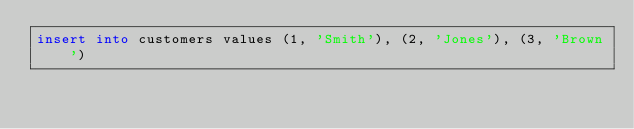Convert code to text. <code><loc_0><loc_0><loc_500><loc_500><_SQL_>insert into customers values (1, 'Smith'), (2, 'Jones'), (3, 'Brown')</code> 